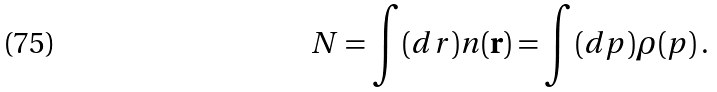Convert formula to latex. <formula><loc_0><loc_0><loc_500><loc_500>N = \int ( d r ) n ( { \mathbf r } ) = \int ( d p ) \rho ( p ) \, .</formula> 